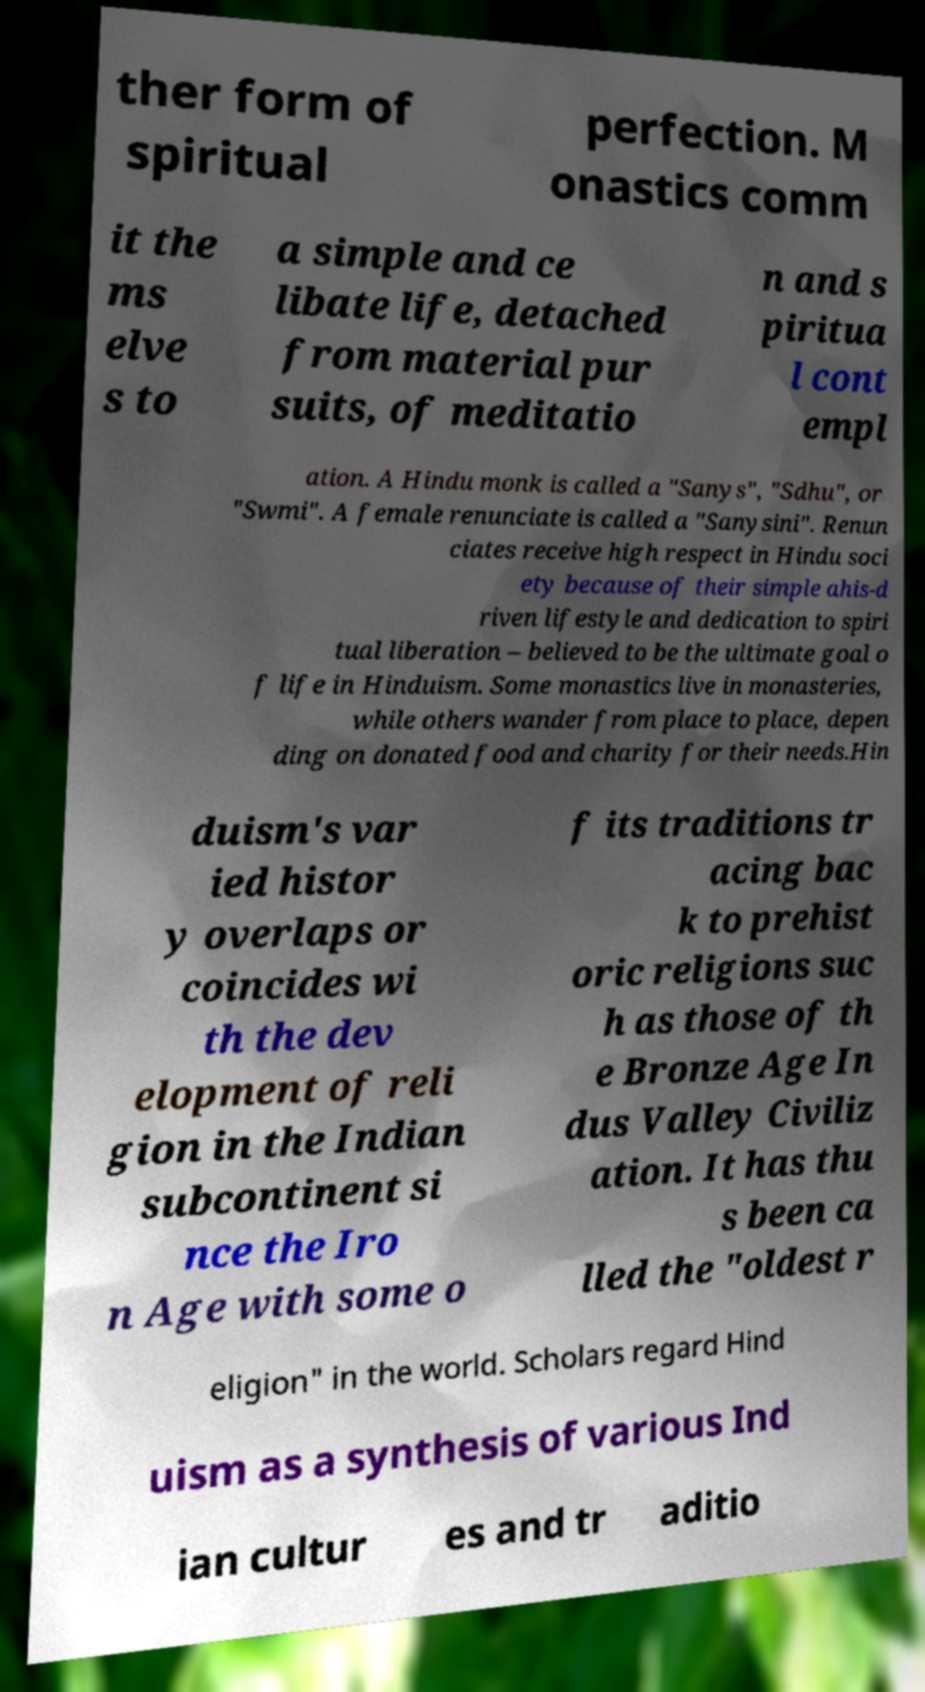Please identify and transcribe the text found in this image. ther form of spiritual perfection. M onastics comm it the ms elve s to a simple and ce libate life, detached from material pur suits, of meditatio n and s piritua l cont empl ation. A Hindu monk is called a "Sanys", "Sdhu", or "Swmi". A female renunciate is called a "Sanysini". Renun ciates receive high respect in Hindu soci ety because of their simple ahis-d riven lifestyle and dedication to spiri tual liberation – believed to be the ultimate goal o f life in Hinduism. Some monastics live in monasteries, while others wander from place to place, depen ding on donated food and charity for their needs.Hin duism's var ied histor y overlaps or coincides wi th the dev elopment of reli gion in the Indian subcontinent si nce the Iro n Age with some o f its traditions tr acing bac k to prehist oric religions suc h as those of th e Bronze Age In dus Valley Civiliz ation. It has thu s been ca lled the "oldest r eligion" in the world. Scholars regard Hind uism as a synthesis of various Ind ian cultur es and tr aditio 